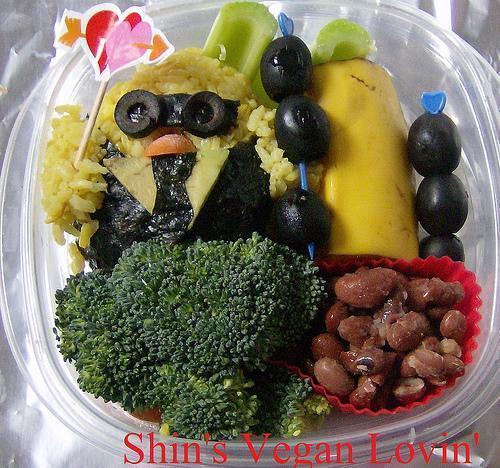How many full olives can be seen?
Give a very brief answer. 6. 